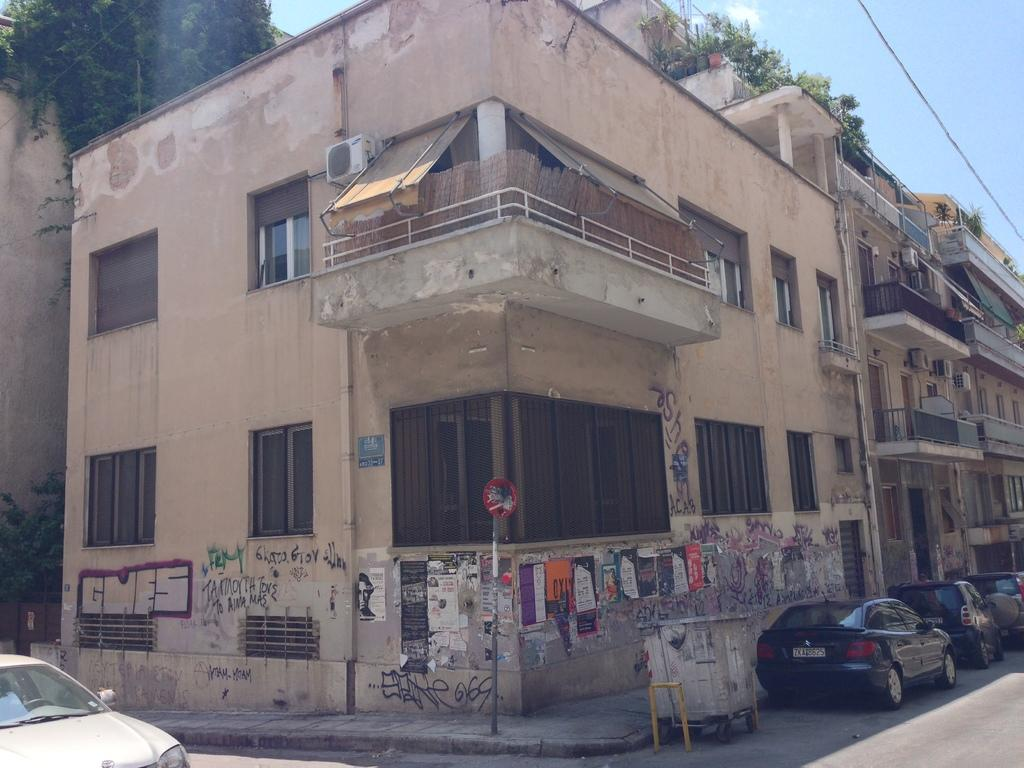What structure is the main subject of the image? There is a building in the image. Are there any objects placed on top of the building? Yes, there are potted plants on top of the building. What can be seen in front of the building? There are cars parked in front of the building. What is visible in the background of the image? The sky is visible in the image. Can you see any deer in the image? No, there are no deer present in the image. Is the ground covered in sleet in the image? The provided facts do not mention any weather conditions, so it cannot be determined if the ground is covered in sleet. 